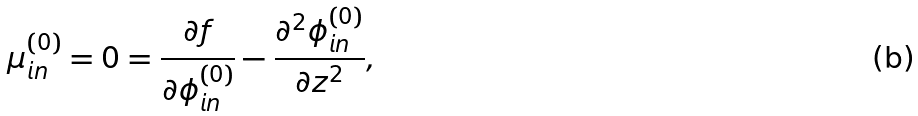<formula> <loc_0><loc_0><loc_500><loc_500>\mu _ { i n } ^ { ( 0 ) } = 0 = \frac { \partial f } { \partial \phi _ { i n } ^ { ( 0 ) } } - \frac { \partial ^ { 2 } \phi _ { i n } ^ { ( 0 ) } } { \partial z ^ { 2 } } ,</formula> 